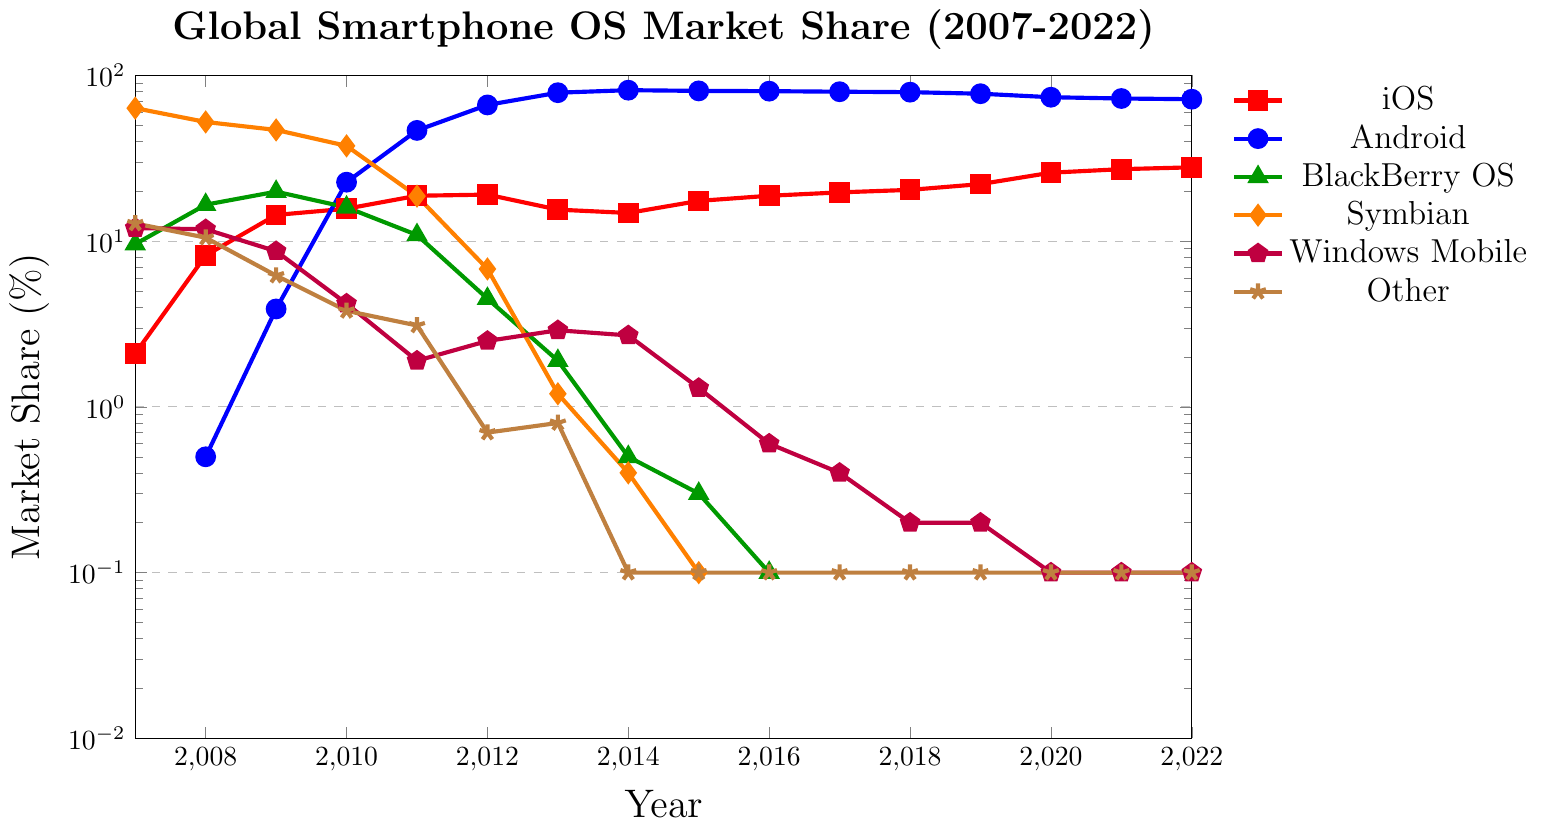What is the market share trend for Android from 2007 to 2022? Android's market share has increased significantly, starting from 0.0% in 2007 and peaking around 81.5% in 2014. It then slightly decreased to 71.9% by 2022.
Answer: Increasing In which year did iOS surpass 20% market share for the first time? By looking at the iOS market share trend, we see that it surpasses 20% for the first time in 2018 with a market share of 22.1%.
Answer: 2019 How does the market share of Android in 2012 compare to that of Symbian in 2007? In 2012, Android's market share was 66.4%, while in 2007, Symbian had a market share of 63.5%. Android had a higher market share in 2012 compared to Symbian's share in 2007.
Answer: Android is higher What was the market share difference between iOS and BlackBerry OS in 2013? In 2013, iOS had a market share of 15.5% and BlackBerry OS had 1.9%. The difference in market share is 15.5% - 1.9% = 13.6%.
Answer: 13.6% By how much did Symbian's market share drop from 2007 to 2012? In 2007, Symbian's market share was 63.5%, and in 2012 it was 6.8%. The drop in market share is 63.5% - 6.8% = 56.7%.
Answer: 56.7% Which operating system had the highest market share in 2014? By examining the data for 2014, the highest market share is held by Android with 81.5%.
Answer: Android Between 2010 and 2011, how did the market share of Android change? Android's market share in 2010 was 22.7% and it increased to 46.6% in 2011. The change in market share is 46.6% - 22.7% = 23.9%.
Answer: Increased by 23.9% What is the trend of Windows Mobile market share from 2009 to 2015? Windows Mobile's market share decreased from 8.7% in 2009 to 1.3% in 2015.
Answer: Decreasing In which year did BlackBerry OS drop to below 1% market share, and what was the exact value that year? BlackBerry OS market share dropped below 1% in 2013, with an exact value of 0.5%.
Answer: 2014, 0.5% What is the lowest market share percentage exhibited by any operating system in the timeframe, and which system and year does it correspond to? Examining the data, the lowest market share is 0.0% which is observed for BlackBerry OS, Symbian, and Windows Mobile in several years.
Answer: BlackBerry OS, Symbian, Windows Mobile, various years 